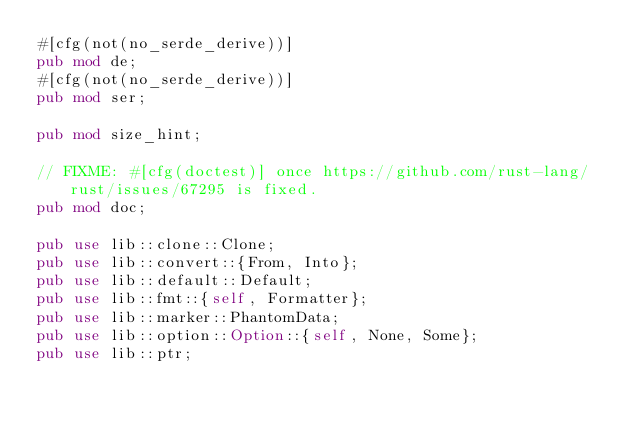<code> <loc_0><loc_0><loc_500><loc_500><_Rust_>#[cfg(not(no_serde_derive))]
pub mod de;
#[cfg(not(no_serde_derive))]
pub mod ser;

pub mod size_hint;

// FIXME: #[cfg(doctest)] once https://github.com/rust-lang/rust/issues/67295 is fixed.
pub mod doc;

pub use lib::clone::Clone;
pub use lib::convert::{From, Into};
pub use lib::default::Default;
pub use lib::fmt::{self, Formatter};
pub use lib::marker::PhantomData;
pub use lib::option::Option::{self, None, Some};
pub use lib::ptr;</code> 